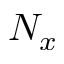<formula> <loc_0><loc_0><loc_500><loc_500>N _ { x }</formula> 